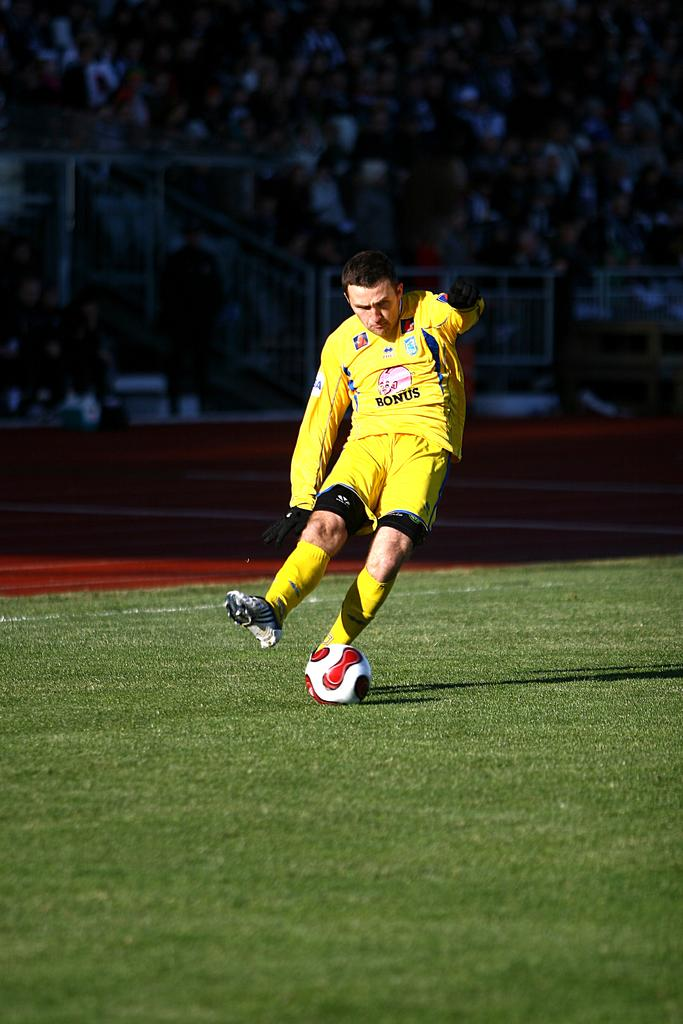What is the person in the image doing? The person in the image is running and kicking a ball. Can you describe the people watching the activity in the image? There is an audience visible in the image. What type of surface is the person running on? The ground is covered with grass. What type of baseball equipment can be seen in the image? There is no baseball equipment present in the image; it features a person running and kicking a ball. What is the representative doing in the image? There is no representative present in the image; it features a person running and kicking a ball and an audience watching the activity. 